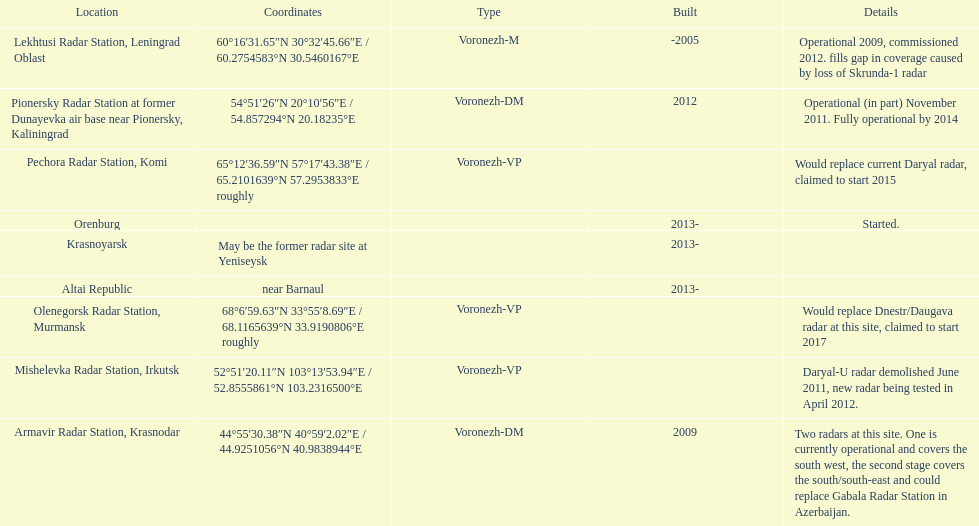How many voronezh radars are in kaliningrad or in krasnodar? 2. 